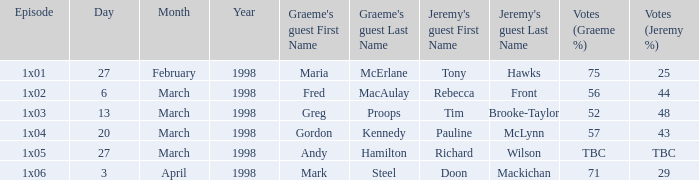What is Votes (%), when First Broadcast is "13 March 1998"? 52–48. 